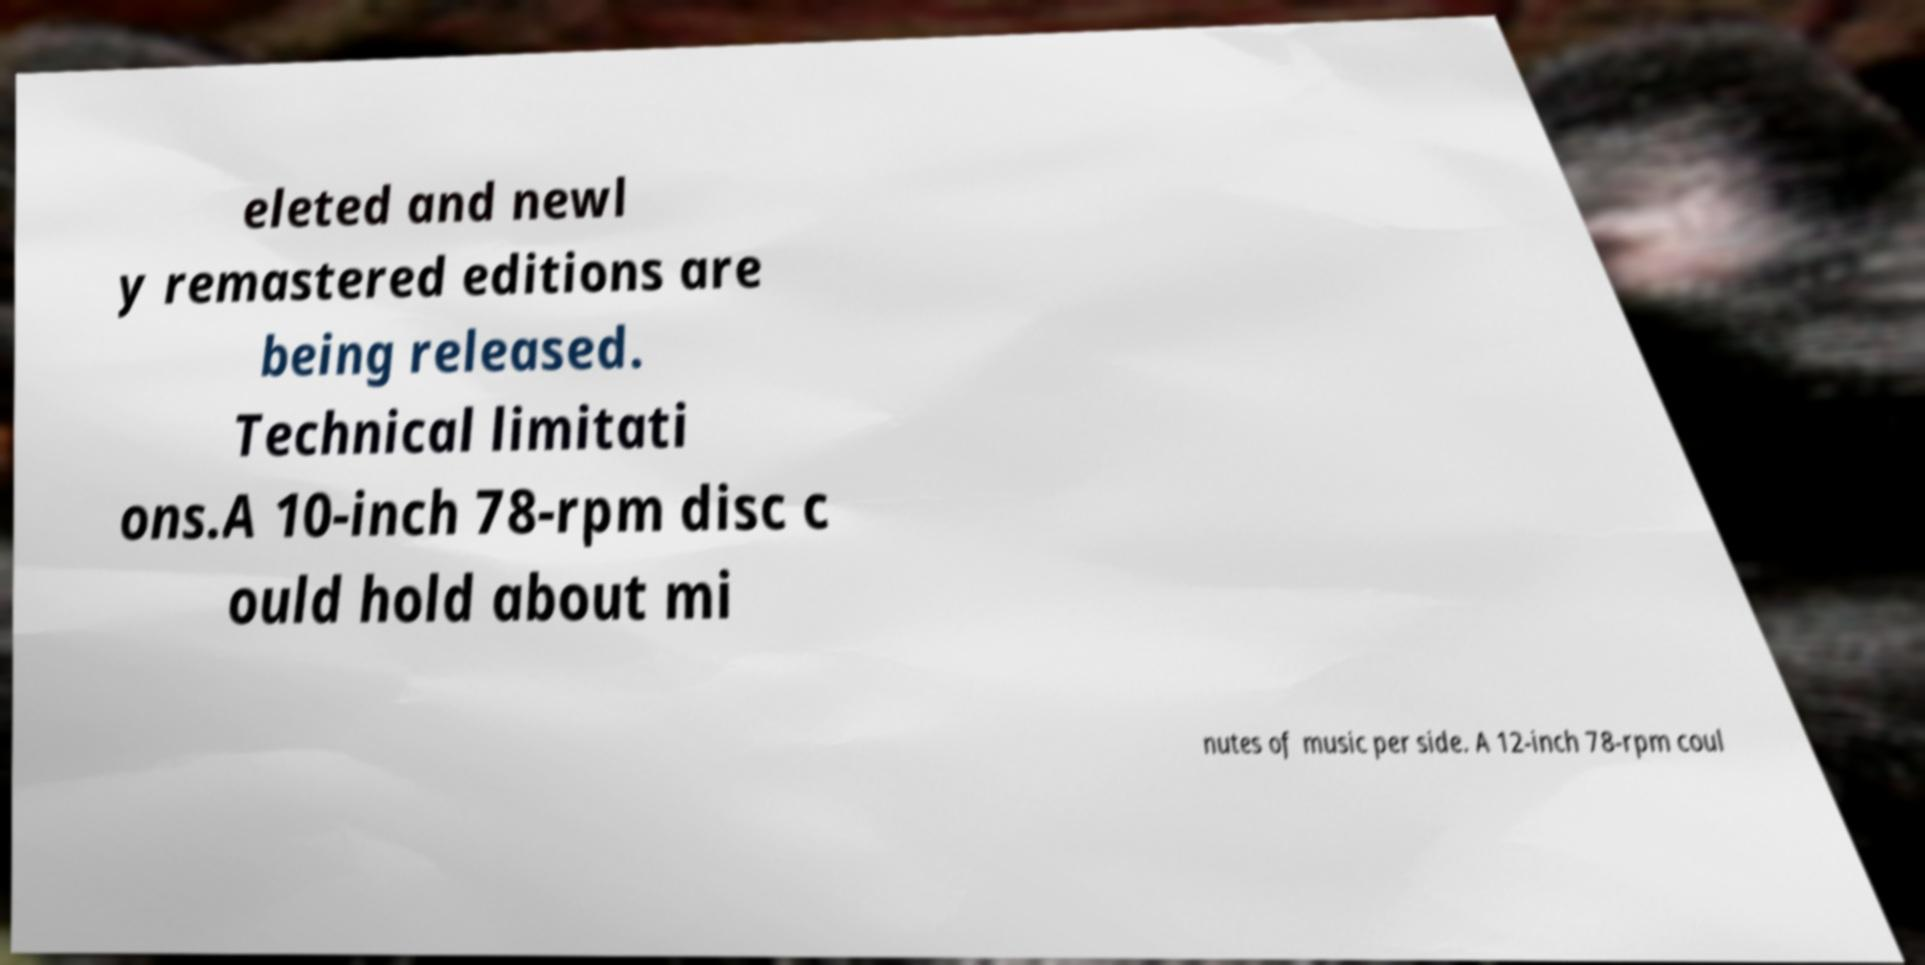Could you assist in decoding the text presented in this image and type it out clearly? eleted and newl y remastered editions are being released. Technical limitati ons.A 10-inch 78-rpm disc c ould hold about mi nutes of music per side. A 12-inch 78-rpm coul 